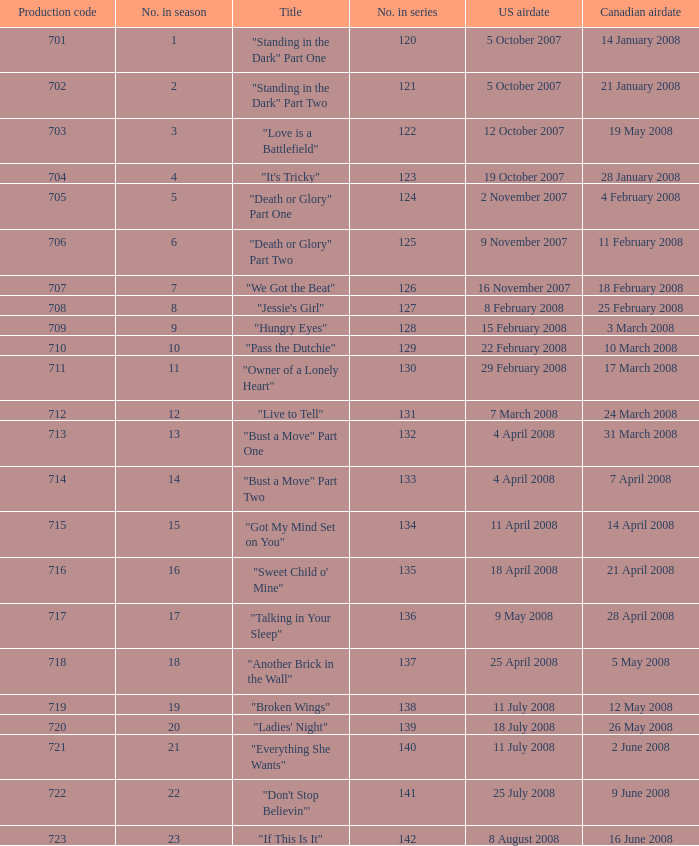The U.S. airdate of 8 august 2008 also had canadian airdates of what? 16 June 2008. 